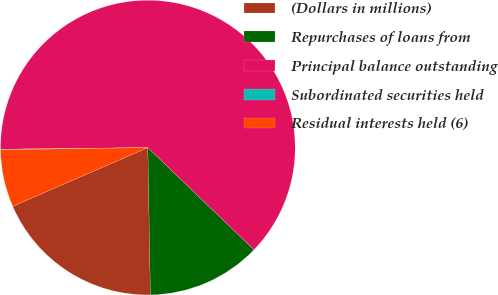Convert chart. <chart><loc_0><loc_0><loc_500><loc_500><pie_chart><fcel>(Dollars in millions)<fcel>Repurchases of loans from<fcel>Principal balance outstanding<fcel>Subordinated securities held<fcel>Residual interests held (6)<nl><fcel>18.75%<fcel>12.52%<fcel>62.36%<fcel>0.06%<fcel>6.29%<nl></chart> 